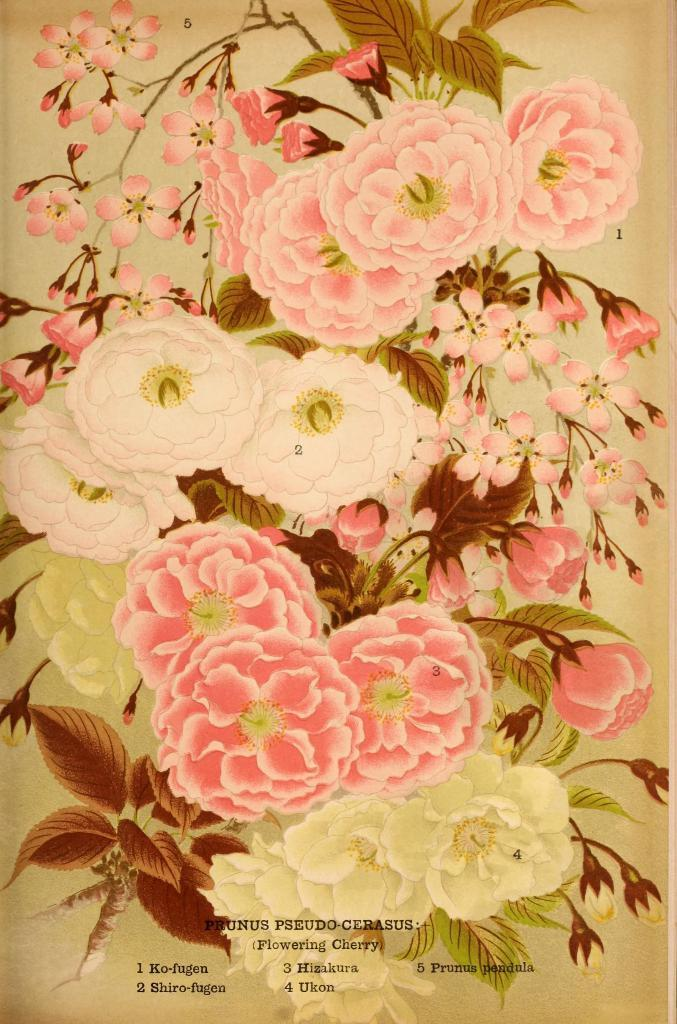What type of image is present in the picture? There is a printed picture in the image. What elements can be found in the printed picture? The picture contains flowers, leaves, and buds. Is there any text present in the image? Yes, there is text on the image. What type of coast can be seen in the image? There is no coast present in the image; it contains a printed picture with flowers, leaves, and buds. What punishment is being given to the flowers in the image? There is no punishment being given to the flowers in the image; it is a still picture of flowers, leaves, and buds. 